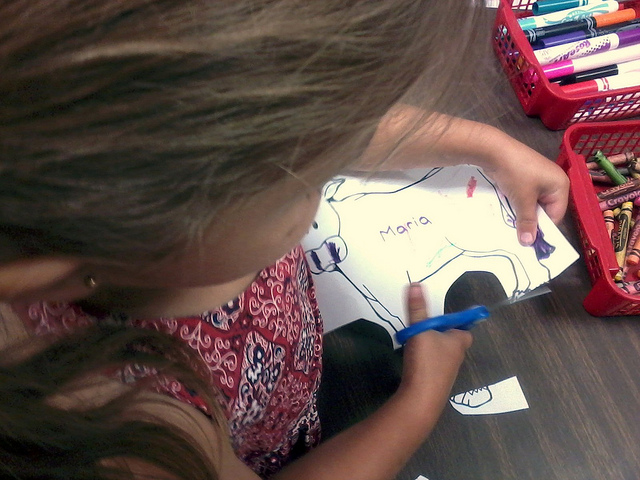Identify the text displayed in this image. Maria Cravou 